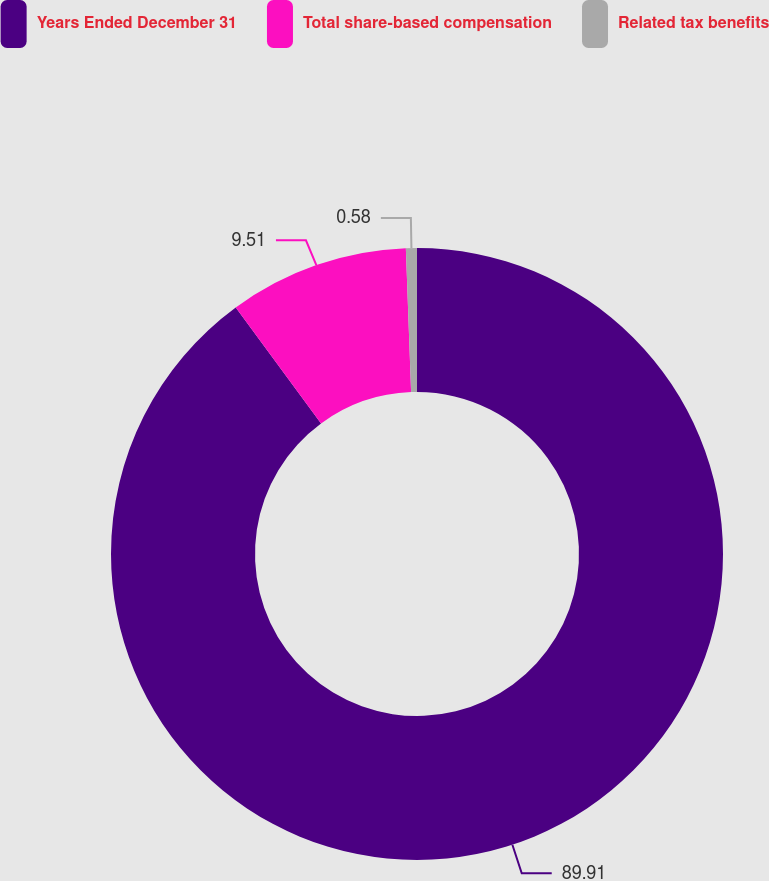Convert chart to OTSL. <chart><loc_0><loc_0><loc_500><loc_500><pie_chart><fcel>Years Ended December 31<fcel>Total share-based compensation<fcel>Related tax benefits<nl><fcel>89.91%<fcel>9.51%<fcel>0.58%<nl></chart> 